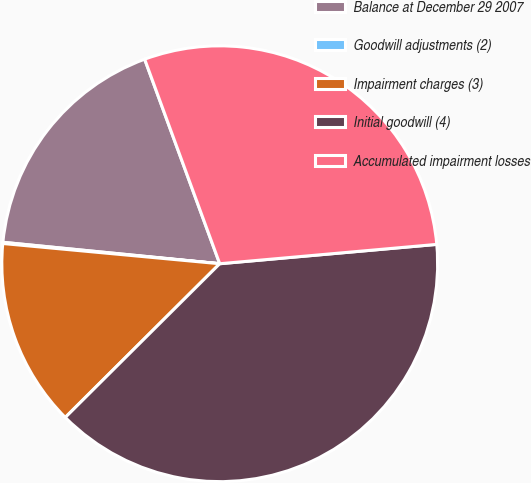Convert chart. <chart><loc_0><loc_0><loc_500><loc_500><pie_chart><fcel>Balance at December 29 2007<fcel>Goodwill adjustments (2)<fcel>Impairment charges (3)<fcel>Initial goodwill (4)<fcel>Accumulated impairment losses<nl><fcel>17.83%<fcel>0.09%<fcel>13.94%<fcel>38.95%<fcel>29.18%<nl></chart> 